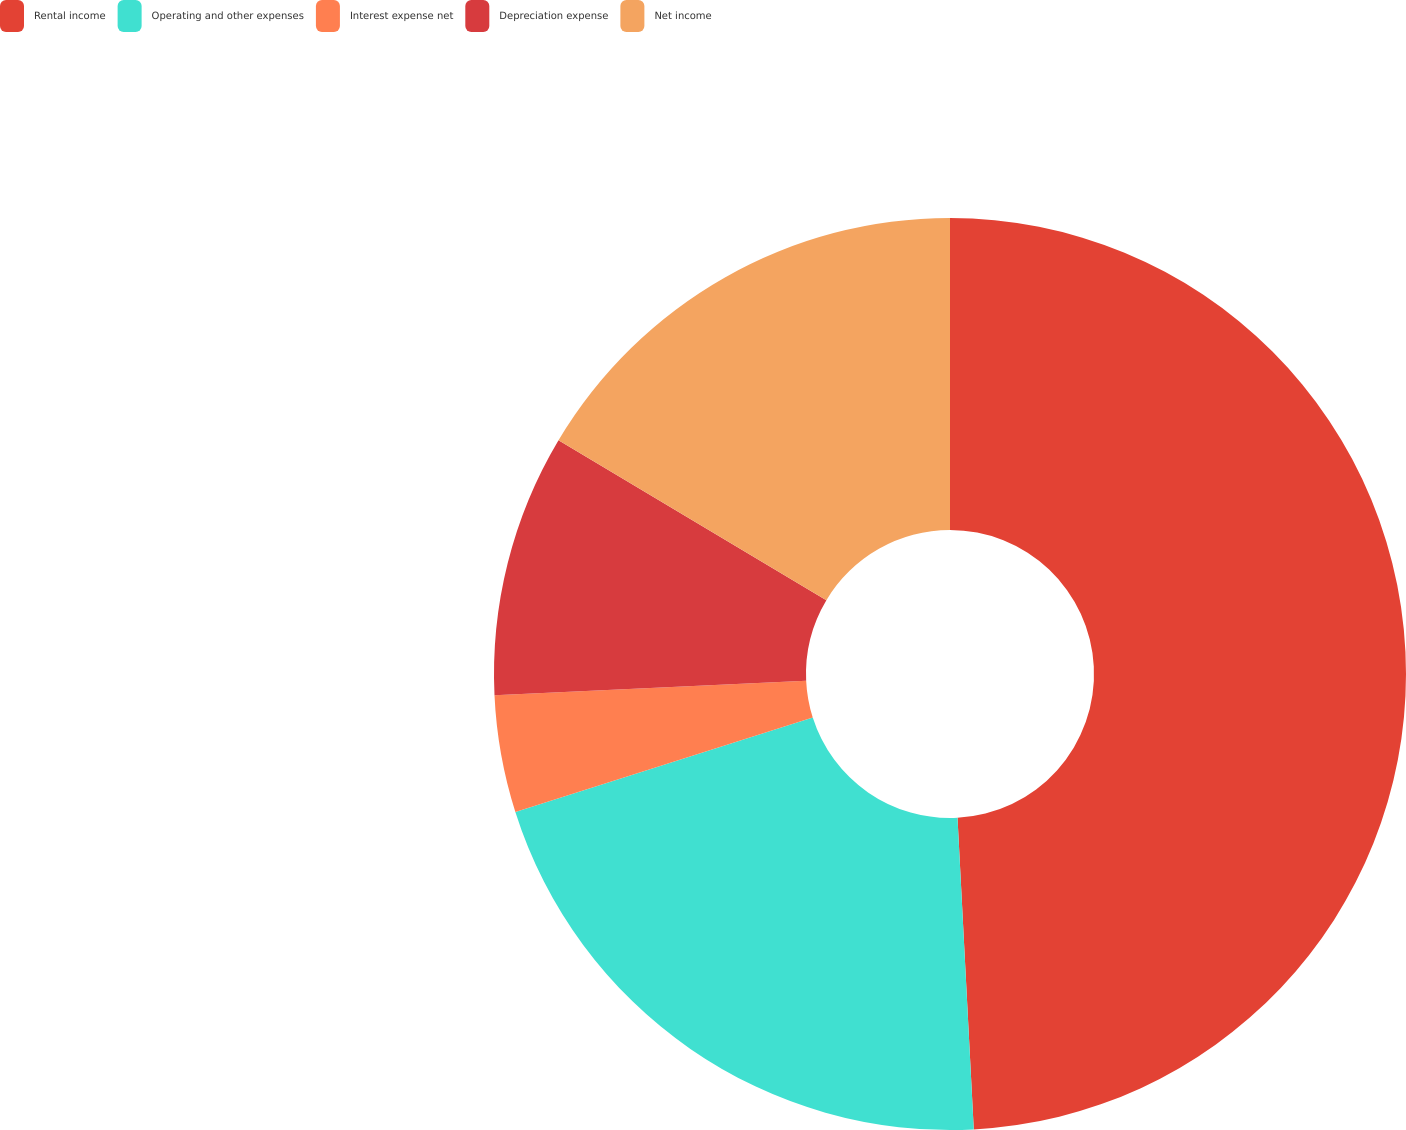Convert chart to OTSL. <chart><loc_0><loc_0><loc_500><loc_500><pie_chart><fcel>Rental income<fcel>Operating and other expenses<fcel>Interest expense net<fcel>Depreciation expense<fcel>Net income<nl><fcel>49.17%<fcel>20.94%<fcel>4.15%<fcel>9.31%<fcel>16.43%<nl></chart> 